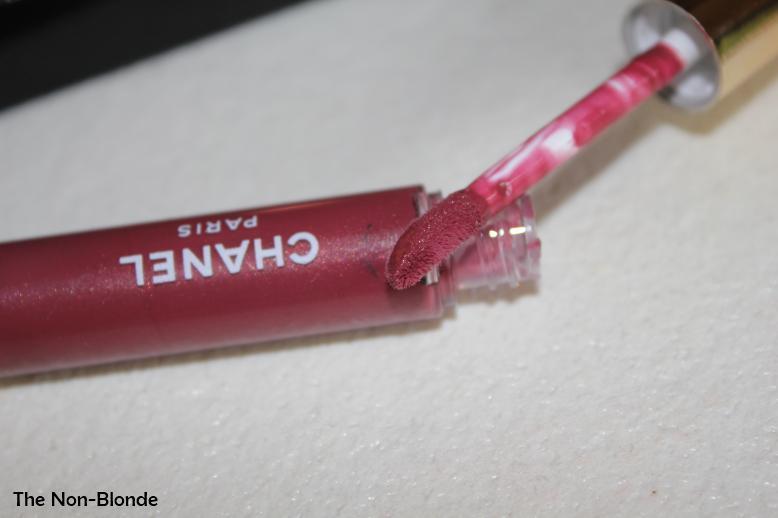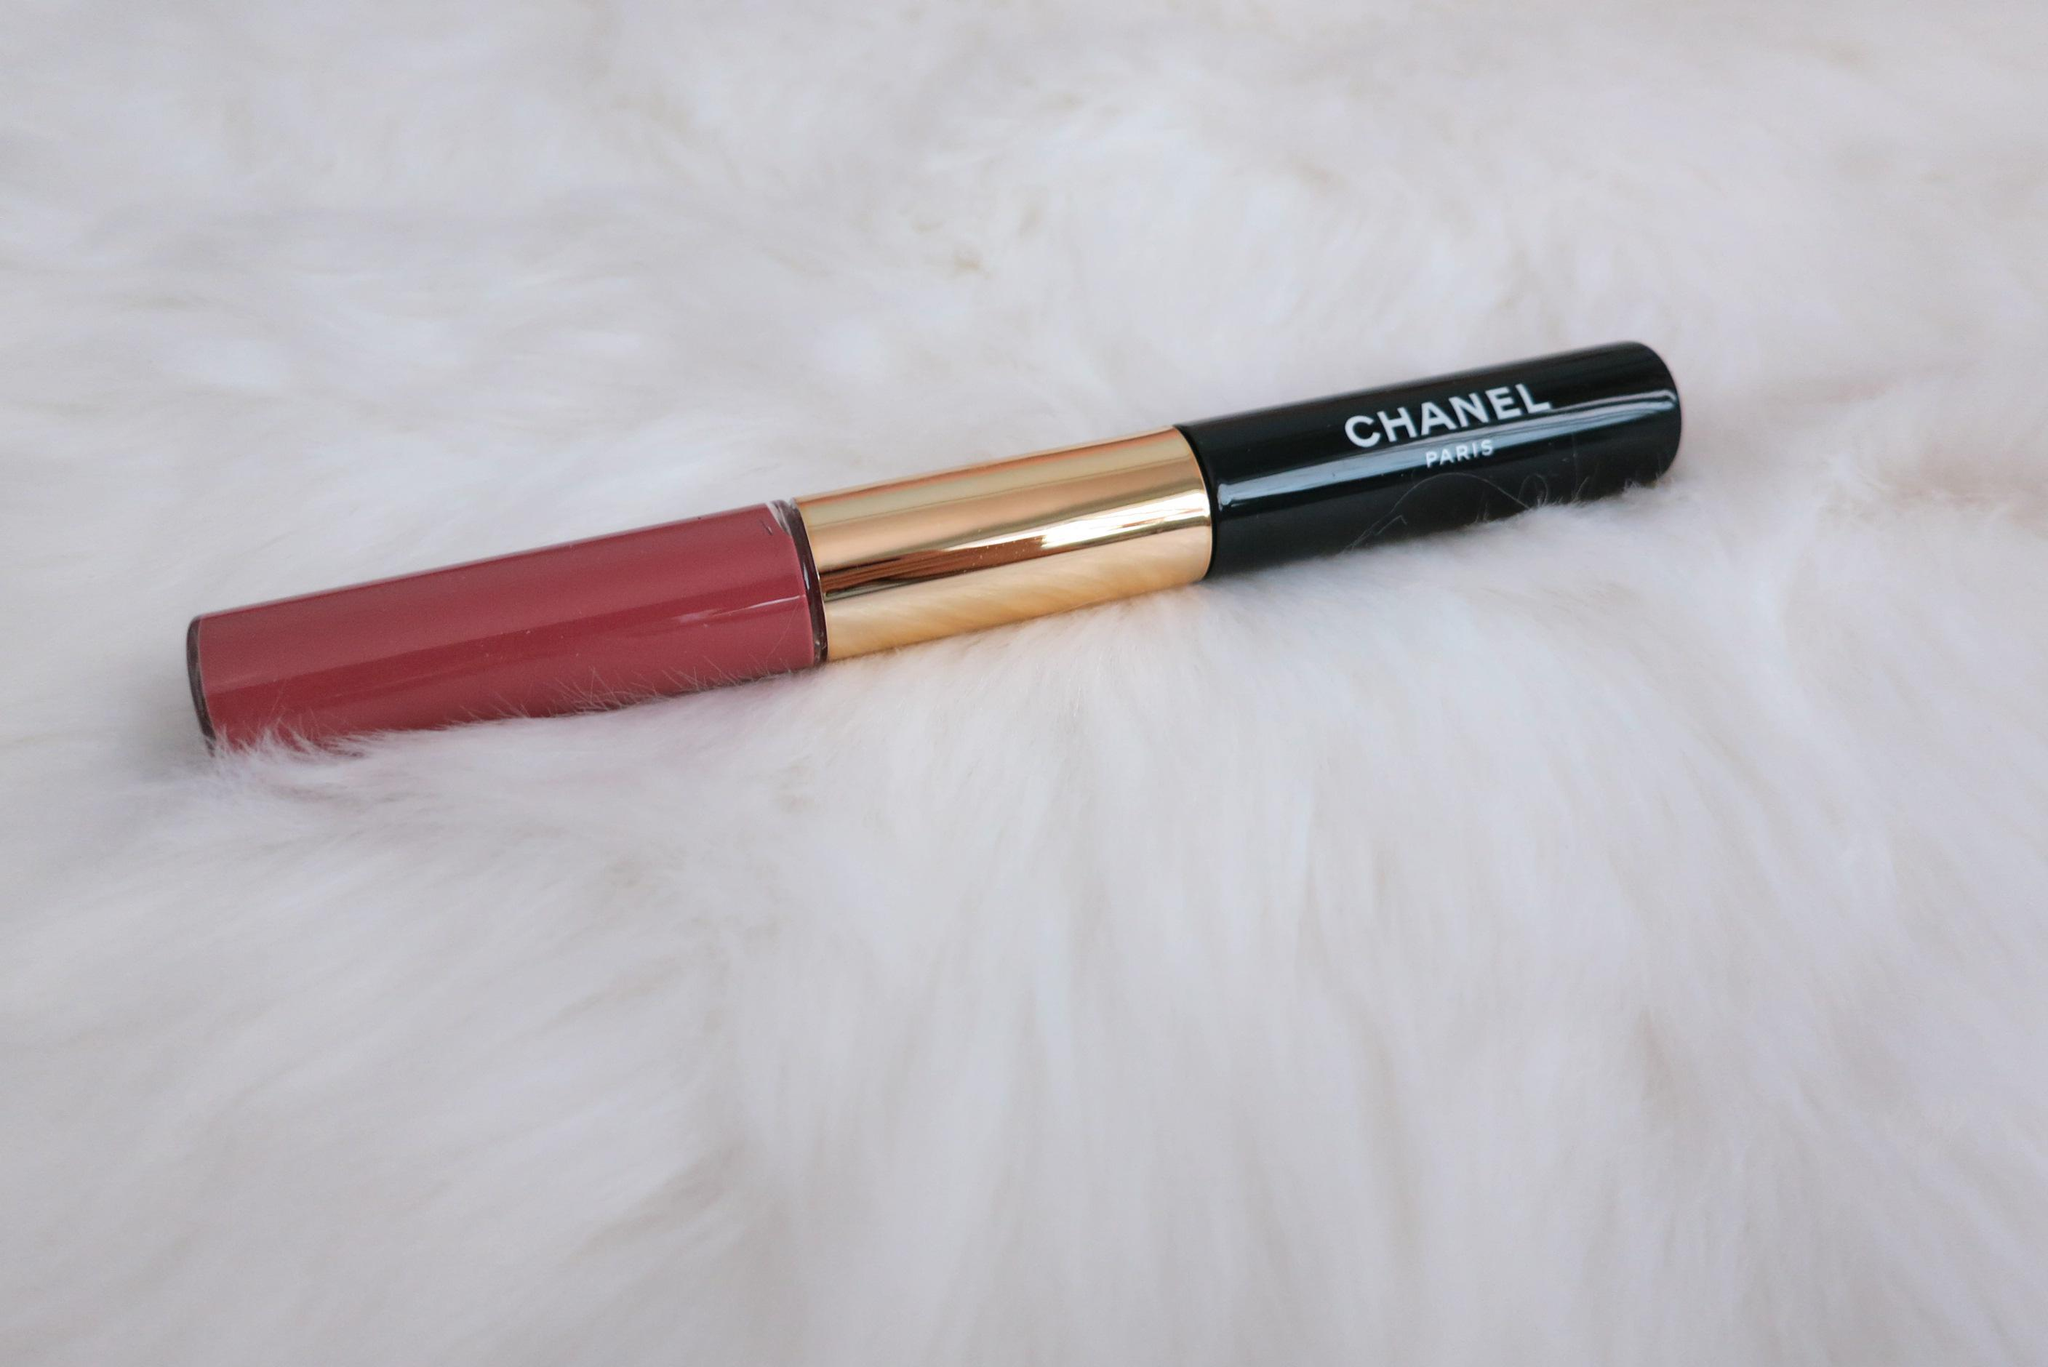The first image is the image on the left, the second image is the image on the right. Examine the images to the left and right. Is the description "There are two tubes of lipstick, and one of them is open while the other one is closed." accurate? Answer yes or no. Yes. The first image is the image on the left, the second image is the image on the right. Assess this claim about the two images: "Left image contains one lipstick with its applicator resting atop its base, and the right image shows one lipstick with its cap on.". Correct or not? Answer yes or no. Yes. 